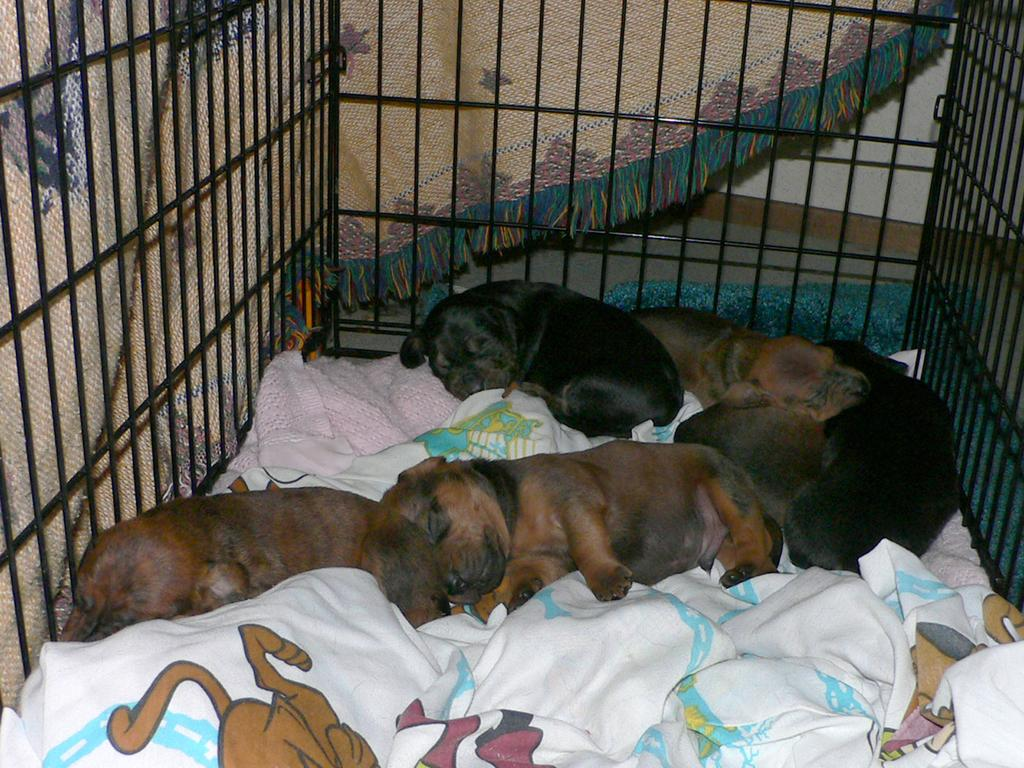What animals are present in the image? There are puppies in the image. What is the puppies resting on? The puppies are on a cloth. Where are the puppies located? The puppies are inside a cage. What else can be seen in the background of the image? There is another cloth visible in the background of the image. Can you see any frogs or yams in the image? No, there are no frogs or yams present in the image. 